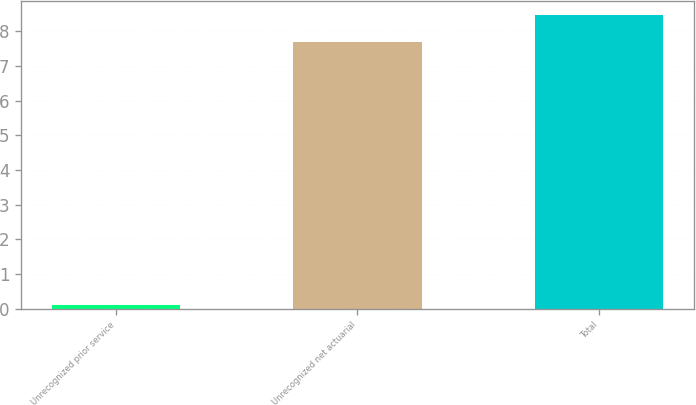<chart> <loc_0><loc_0><loc_500><loc_500><bar_chart><fcel>Unrecognized prior service<fcel>Unrecognized net actuarial<fcel>Total<nl><fcel>0.1<fcel>7.7<fcel>8.47<nl></chart> 